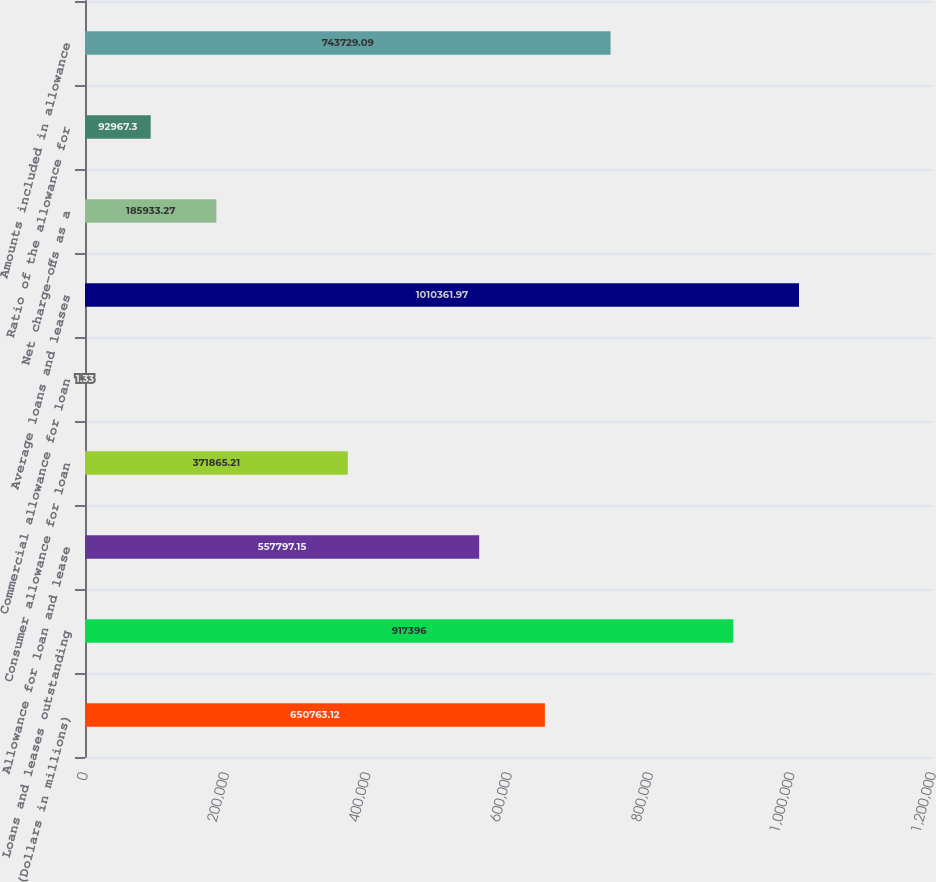Convert chart. <chart><loc_0><loc_0><loc_500><loc_500><bar_chart><fcel>(Dollars in millions)<fcel>Loans and leases outstanding<fcel>Allowance for loan and lease<fcel>Consumer allowance for loan<fcel>Commercial allowance for loan<fcel>Average loans and leases<fcel>Net charge-offs as a<fcel>Ratio of the allowance for<fcel>Amounts included in allowance<nl><fcel>650763<fcel>917396<fcel>557797<fcel>371865<fcel>1.33<fcel>1.01036e+06<fcel>185933<fcel>92967.3<fcel>743729<nl></chart> 